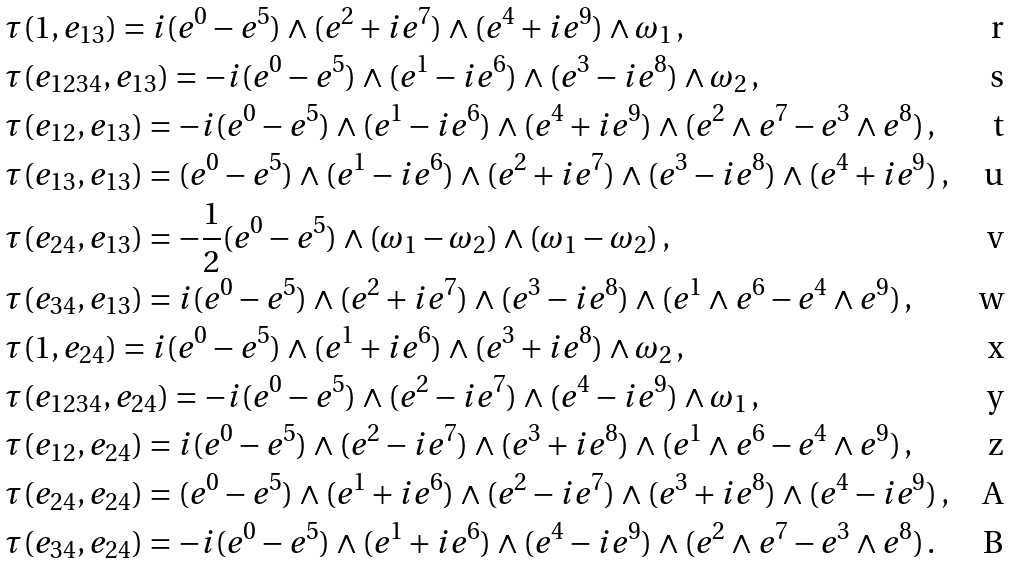Convert formula to latex. <formula><loc_0><loc_0><loc_500><loc_500>& \tau ( 1 , e _ { 1 3 } ) = i ( e ^ { 0 } - e ^ { 5 } ) \wedge ( e ^ { 2 } + i e ^ { 7 } ) \wedge ( e ^ { 4 } + i e ^ { 9 } ) \wedge \omega _ { 1 } \, , \\ & \tau ( e _ { 1 2 3 4 } , e _ { 1 3 } ) = - i ( e ^ { 0 } - e ^ { 5 } ) \wedge ( e ^ { 1 } - i e ^ { 6 } ) \wedge ( e ^ { 3 } - i e ^ { 8 } ) \wedge \omega _ { 2 } \, , \\ & \tau ( e _ { 1 2 } , e _ { 1 3 } ) = - i ( e ^ { 0 } - e ^ { 5 } ) \wedge ( e ^ { 1 } - i e ^ { 6 } ) \wedge ( e ^ { 4 } + i e ^ { 9 } ) \wedge ( e ^ { 2 } \wedge e ^ { 7 } - e ^ { 3 } \wedge e ^ { 8 } ) \, , \\ & \tau ( e _ { 1 3 } , e _ { 1 3 } ) = ( e ^ { 0 } - e ^ { 5 } ) \wedge ( e ^ { 1 } - i e ^ { 6 } ) \wedge ( e ^ { 2 } + i e ^ { 7 } ) \wedge ( e ^ { 3 } - i e ^ { 8 } ) \wedge ( e ^ { 4 } + i e ^ { 9 } ) \, , \\ & \tau ( e _ { 2 4 } , e _ { 1 3 } ) = - \frac { 1 } { 2 } ( e ^ { 0 } - e ^ { 5 } ) \wedge ( \omega _ { 1 } - \omega _ { 2 } ) \wedge ( \omega _ { 1 } - \omega _ { 2 } ) \, , \\ & \tau ( e _ { 3 4 } , e _ { 1 3 } ) = i ( e ^ { 0 } - e ^ { 5 } ) \wedge ( e ^ { 2 } + i e ^ { 7 } ) \wedge ( e ^ { 3 } - i e ^ { 8 } ) \wedge ( e ^ { 1 } \wedge e ^ { 6 } - e ^ { 4 } \wedge e ^ { 9 } ) \, , \\ & \tau ( 1 , e _ { 2 4 } ) = i ( e ^ { 0 } - e ^ { 5 } ) \wedge ( e ^ { 1 } + i e ^ { 6 } ) \wedge ( e ^ { 3 } + i e ^ { 8 } ) \wedge \omega _ { 2 } \, , \\ & \tau ( e _ { 1 2 3 4 } , e _ { 2 4 } ) = - i ( e ^ { 0 } - e ^ { 5 } ) \wedge ( e ^ { 2 } - i e ^ { 7 } ) \wedge ( e ^ { 4 } - i e ^ { 9 } ) \wedge \omega _ { 1 } \, , \\ & \tau ( e _ { 1 2 } , e _ { 2 4 } ) = i ( e ^ { 0 } - e ^ { 5 } ) \wedge ( e ^ { 2 } - i e ^ { 7 } ) \wedge ( e ^ { 3 } + i e ^ { 8 } ) \wedge ( e ^ { 1 } \wedge e ^ { 6 } - e ^ { 4 } \wedge e ^ { 9 } ) \, , \\ & \tau ( e _ { 2 4 } , e _ { 2 4 } ) = ( e ^ { 0 } - e ^ { 5 } ) \wedge ( e ^ { 1 } + i e ^ { 6 } ) \wedge ( e ^ { 2 } - i e ^ { 7 } ) \wedge ( e ^ { 3 } + i e ^ { 8 } ) \wedge ( e ^ { 4 } - i e ^ { 9 } ) \, , \\ & \tau ( e _ { 3 4 } , e _ { 2 4 } ) = - i ( e ^ { 0 } - e ^ { 5 } ) \wedge ( e ^ { 1 } + i e ^ { 6 } ) \wedge ( e ^ { 4 } - i e ^ { 9 } ) \wedge ( e ^ { 2 } \wedge e ^ { 7 } - e ^ { 3 } \wedge e ^ { 8 } ) \, .</formula> 